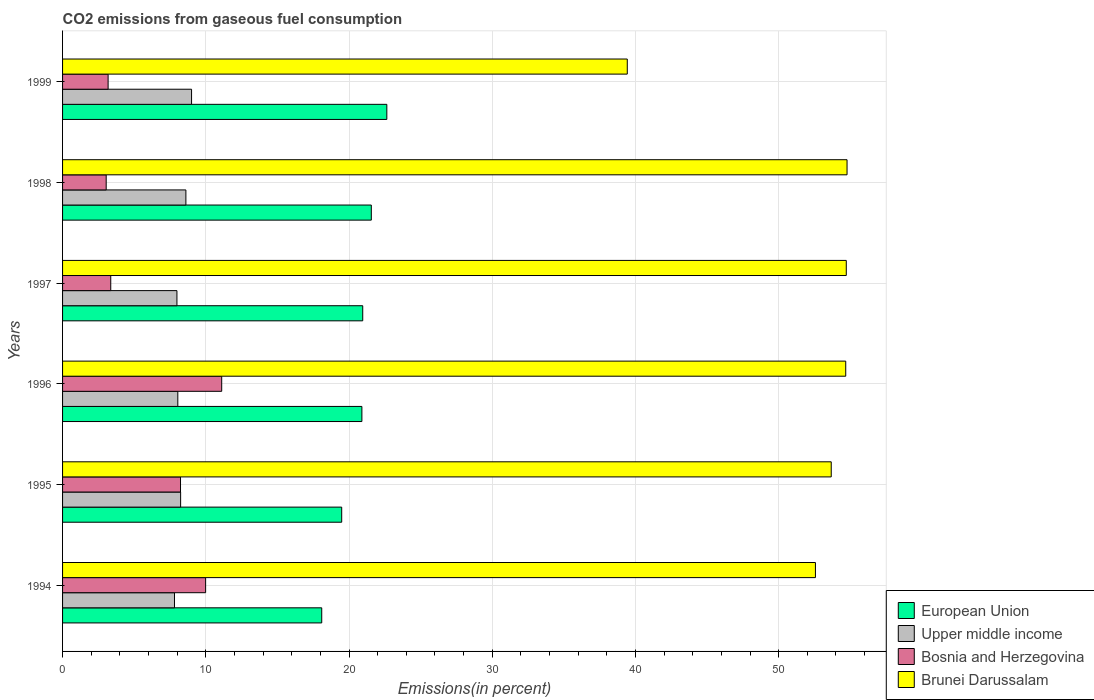Are the number of bars per tick equal to the number of legend labels?
Ensure brevity in your answer.  Yes. Are the number of bars on each tick of the Y-axis equal?
Offer a terse response. Yes. How many bars are there on the 2nd tick from the top?
Your answer should be very brief. 4. How many bars are there on the 2nd tick from the bottom?
Make the answer very short. 4. What is the total CO2 emitted in Bosnia and Herzegovina in 1997?
Provide a short and direct response. 3.36. Across all years, what is the maximum total CO2 emitted in Upper middle income?
Provide a succinct answer. 9.01. Across all years, what is the minimum total CO2 emitted in Bosnia and Herzegovina?
Provide a succinct answer. 3.05. In which year was the total CO2 emitted in European Union minimum?
Your answer should be very brief. 1994. What is the total total CO2 emitted in Bosnia and Herzegovina in the graph?
Your answer should be very brief. 38.93. What is the difference between the total CO2 emitted in Upper middle income in 1998 and that in 1999?
Offer a very short reply. -0.4. What is the difference between the total CO2 emitted in Bosnia and Herzegovina in 1997 and the total CO2 emitted in Brunei Darussalam in 1995?
Your answer should be compact. -50.31. What is the average total CO2 emitted in Upper middle income per year?
Give a very brief answer. 8.28. In the year 1995, what is the difference between the total CO2 emitted in European Union and total CO2 emitted in Bosnia and Herzegovina?
Your answer should be very brief. 11.25. What is the ratio of the total CO2 emitted in Brunei Darussalam in 1996 to that in 1999?
Your answer should be very brief. 1.39. Is the difference between the total CO2 emitted in European Union in 1997 and 1998 greater than the difference between the total CO2 emitted in Bosnia and Herzegovina in 1997 and 1998?
Provide a short and direct response. No. What is the difference between the highest and the second highest total CO2 emitted in Brunei Darussalam?
Your response must be concise. 0.05. What is the difference between the highest and the lowest total CO2 emitted in Brunei Darussalam?
Give a very brief answer. 15.34. In how many years, is the total CO2 emitted in Bosnia and Herzegovina greater than the average total CO2 emitted in Bosnia and Herzegovina taken over all years?
Provide a short and direct response. 3. Is it the case that in every year, the sum of the total CO2 emitted in European Union and total CO2 emitted in Upper middle income is greater than the sum of total CO2 emitted in Brunei Darussalam and total CO2 emitted in Bosnia and Herzegovina?
Your answer should be very brief. Yes. What does the 2nd bar from the top in 1999 represents?
Make the answer very short. Bosnia and Herzegovina. What does the 2nd bar from the bottom in 1996 represents?
Provide a short and direct response. Upper middle income. What is the difference between two consecutive major ticks on the X-axis?
Your response must be concise. 10. Are the values on the major ticks of X-axis written in scientific E-notation?
Offer a terse response. No. Does the graph contain any zero values?
Give a very brief answer. No. How are the legend labels stacked?
Make the answer very short. Vertical. What is the title of the graph?
Offer a very short reply. CO2 emissions from gaseous fuel consumption. What is the label or title of the X-axis?
Give a very brief answer. Emissions(in percent). What is the Emissions(in percent) of European Union in 1994?
Ensure brevity in your answer.  18.09. What is the Emissions(in percent) of Upper middle income in 1994?
Your answer should be very brief. 7.81. What is the Emissions(in percent) of Bosnia and Herzegovina in 1994?
Ensure brevity in your answer.  9.99. What is the Emissions(in percent) in Brunei Darussalam in 1994?
Ensure brevity in your answer.  52.57. What is the Emissions(in percent) of European Union in 1995?
Offer a very short reply. 19.49. What is the Emissions(in percent) of Upper middle income in 1995?
Make the answer very short. 8.24. What is the Emissions(in percent) of Bosnia and Herzegovina in 1995?
Your answer should be very brief. 8.24. What is the Emissions(in percent) of Brunei Darussalam in 1995?
Make the answer very short. 53.67. What is the Emissions(in percent) of European Union in 1996?
Your answer should be compact. 20.9. What is the Emissions(in percent) of Upper middle income in 1996?
Ensure brevity in your answer.  8.05. What is the Emissions(in percent) in Bosnia and Herzegovina in 1996?
Provide a short and direct response. 11.11. What is the Emissions(in percent) of Brunei Darussalam in 1996?
Keep it short and to the point. 54.68. What is the Emissions(in percent) in European Union in 1997?
Your answer should be very brief. 20.96. What is the Emissions(in percent) in Upper middle income in 1997?
Provide a short and direct response. 7.99. What is the Emissions(in percent) in Bosnia and Herzegovina in 1997?
Your answer should be compact. 3.36. What is the Emissions(in percent) in Brunei Darussalam in 1997?
Offer a terse response. 54.72. What is the Emissions(in percent) of European Union in 1998?
Offer a terse response. 21.56. What is the Emissions(in percent) in Upper middle income in 1998?
Your response must be concise. 8.61. What is the Emissions(in percent) of Bosnia and Herzegovina in 1998?
Your answer should be very brief. 3.05. What is the Emissions(in percent) of Brunei Darussalam in 1998?
Provide a short and direct response. 54.77. What is the Emissions(in percent) in European Union in 1999?
Offer a terse response. 22.64. What is the Emissions(in percent) in Upper middle income in 1999?
Your answer should be compact. 9.01. What is the Emissions(in percent) in Bosnia and Herzegovina in 1999?
Provide a succinct answer. 3.18. What is the Emissions(in percent) in Brunei Darussalam in 1999?
Make the answer very short. 39.43. Across all years, what is the maximum Emissions(in percent) in European Union?
Your response must be concise. 22.64. Across all years, what is the maximum Emissions(in percent) of Upper middle income?
Give a very brief answer. 9.01. Across all years, what is the maximum Emissions(in percent) of Bosnia and Herzegovina?
Ensure brevity in your answer.  11.11. Across all years, what is the maximum Emissions(in percent) of Brunei Darussalam?
Ensure brevity in your answer.  54.77. Across all years, what is the minimum Emissions(in percent) of European Union?
Give a very brief answer. 18.09. Across all years, what is the minimum Emissions(in percent) of Upper middle income?
Give a very brief answer. 7.81. Across all years, what is the minimum Emissions(in percent) of Bosnia and Herzegovina?
Provide a short and direct response. 3.05. Across all years, what is the minimum Emissions(in percent) in Brunei Darussalam?
Your answer should be very brief. 39.43. What is the total Emissions(in percent) of European Union in the graph?
Provide a short and direct response. 123.64. What is the total Emissions(in percent) in Upper middle income in the graph?
Ensure brevity in your answer.  49.71. What is the total Emissions(in percent) in Bosnia and Herzegovina in the graph?
Offer a terse response. 38.93. What is the total Emissions(in percent) in Brunei Darussalam in the graph?
Offer a terse response. 309.84. What is the difference between the Emissions(in percent) of European Union in 1994 and that in 1995?
Your response must be concise. -1.39. What is the difference between the Emissions(in percent) in Upper middle income in 1994 and that in 1995?
Provide a succinct answer. -0.43. What is the difference between the Emissions(in percent) of Bosnia and Herzegovina in 1994 and that in 1995?
Make the answer very short. 1.75. What is the difference between the Emissions(in percent) in Brunei Darussalam in 1994 and that in 1995?
Ensure brevity in your answer.  -1.1. What is the difference between the Emissions(in percent) in European Union in 1994 and that in 1996?
Your response must be concise. -2.8. What is the difference between the Emissions(in percent) of Upper middle income in 1994 and that in 1996?
Make the answer very short. -0.23. What is the difference between the Emissions(in percent) of Bosnia and Herzegovina in 1994 and that in 1996?
Offer a terse response. -1.12. What is the difference between the Emissions(in percent) of Brunei Darussalam in 1994 and that in 1996?
Keep it short and to the point. -2.11. What is the difference between the Emissions(in percent) of European Union in 1994 and that in 1997?
Your answer should be compact. -2.86. What is the difference between the Emissions(in percent) of Upper middle income in 1994 and that in 1997?
Provide a succinct answer. -0.17. What is the difference between the Emissions(in percent) in Bosnia and Herzegovina in 1994 and that in 1997?
Make the answer very short. 6.62. What is the difference between the Emissions(in percent) in Brunei Darussalam in 1994 and that in 1997?
Ensure brevity in your answer.  -2.15. What is the difference between the Emissions(in percent) of European Union in 1994 and that in 1998?
Make the answer very short. -3.46. What is the difference between the Emissions(in percent) of Upper middle income in 1994 and that in 1998?
Make the answer very short. -0.8. What is the difference between the Emissions(in percent) in Bosnia and Herzegovina in 1994 and that in 1998?
Make the answer very short. 6.94. What is the difference between the Emissions(in percent) of Brunei Darussalam in 1994 and that in 1998?
Give a very brief answer. -2.21. What is the difference between the Emissions(in percent) in European Union in 1994 and that in 1999?
Provide a short and direct response. -4.55. What is the difference between the Emissions(in percent) in Upper middle income in 1994 and that in 1999?
Provide a short and direct response. -1.19. What is the difference between the Emissions(in percent) of Bosnia and Herzegovina in 1994 and that in 1999?
Provide a succinct answer. 6.81. What is the difference between the Emissions(in percent) of Brunei Darussalam in 1994 and that in 1999?
Provide a succinct answer. 13.14. What is the difference between the Emissions(in percent) of European Union in 1995 and that in 1996?
Your answer should be very brief. -1.41. What is the difference between the Emissions(in percent) of Upper middle income in 1995 and that in 1996?
Your response must be concise. 0.2. What is the difference between the Emissions(in percent) of Bosnia and Herzegovina in 1995 and that in 1996?
Provide a short and direct response. -2.88. What is the difference between the Emissions(in percent) in Brunei Darussalam in 1995 and that in 1996?
Keep it short and to the point. -1.01. What is the difference between the Emissions(in percent) in European Union in 1995 and that in 1997?
Offer a terse response. -1.47. What is the difference between the Emissions(in percent) in Upper middle income in 1995 and that in 1997?
Your answer should be compact. 0.26. What is the difference between the Emissions(in percent) of Bosnia and Herzegovina in 1995 and that in 1997?
Give a very brief answer. 4.87. What is the difference between the Emissions(in percent) in Brunei Darussalam in 1995 and that in 1997?
Keep it short and to the point. -1.05. What is the difference between the Emissions(in percent) of European Union in 1995 and that in 1998?
Make the answer very short. -2.07. What is the difference between the Emissions(in percent) of Upper middle income in 1995 and that in 1998?
Your response must be concise. -0.37. What is the difference between the Emissions(in percent) of Bosnia and Herzegovina in 1995 and that in 1998?
Your response must be concise. 5.19. What is the difference between the Emissions(in percent) in Brunei Darussalam in 1995 and that in 1998?
Ensure brevity in your answer.  -1.1. What is the difference between the Emissions(in percent) of European Union in 1995 and that in 1999?
Provide a short and direct response. -3.15. What is the difference between the Emissions(in percent) in Upper middle income in 1995 and that in 1999?
Make the answer very short. -0.76. What is the difference between the Emissions(in percent) in Bosnia and Herzegovina in 1995 and that in 1999?
Give a very brief answer. 5.06. What is the difference between the Emissions(in percent) in Brunei Darussalam in 1995 and that in 1999?
Offer a terse response. 14.24. What is the difference between the Emissions(in percent) of European Union in 1996 and that in 1997?
Provide a succinct answer. -0.06. What is the difference between the Emissions(in percent) in Upper middle income in 1996 and that in 1997?
Provide a short and direct response. 0.06. What is the difference between the Emissions(in percent) of Bosnia and Herzegovina in 1996 and that in 1997?
Your answer should be very brief. 7.75. What is the difference between the Emissions(in percent) of Brunei Darussalam in 1996 and that in 1997?
Ensure brevity in your answer.  -0.04. What is the difference between the Emissions(in percent) of European Union in 1996 and that in 1998?
Offer a very short reply. -0.66. What is the difference between the Emissions(in percent) of Upper middle income in 1996 and that in 1998?
Give a very brief answer. -0.56. What is the difference between the Emissions(in percent) of Bosnia and Herzegovina in 1996 and that in 1998?
Your response must be concise. 8.07. What is the difference between the Emissions(in percent) in Brunei Darussalam in 1996 and that in 1998?
Your answer should be compact. -0.09. What is the difference between the Emissions(in percent) in European Union in 1996 and that in 1999?
Your answer should be very brief. -1.74. What is the difference between the Emissions(in percent) in Upper middle income in 1996 and that in 1999?
Your answer should be very brief. -0.96. What is the difference between the Emissions(in percent) of Bosnia and Herzegovina in 1996 and that in 1999?
Your answer should be compact. 7.93. What is the difference between the Emissions(in percent) of Brunei Darussalam in 1996 and that in 1999?
Offer a terse response. 15.25. What is the difference between the Emissions(in percent) of European Union in 1997 and that in 1998?
Give a very brief answer. -0.6. What is the difference between the Emissions(in percent) in Upper middle income in 1997 and that in 1998?
Your answer should be very brief. -0.62. What is the difference between the Emissions(in percent) of Bosnia and Herzegovina in 1997 and that in 1998?
Give a very brief answer. 0.32. What is the difference between the Emissions(in percent) of Brunei Darussalam in 1997 and that in 1998?
Your answer should be very brief. -0.05. What is the difference between the Emissions(in percent) of European Union in 1997 and that in 1999?
Give a very brief answer. -1.68. What is the difference between the Emissions(in percent) in Upper middle income in 1997 and that in 1999?
Offer a very short reply. -1.02. What is the difference between the Emissions(in percent) of Bosnia and Herzegovina in 1997 and that in 1999?
Your answer should be very brief. 0.18. What is the difference between the Emissions(in percent) in Brunei Darussalam in 1997 and that in 1999?
Your response must be concise. 15.29. What is the difference between the Emissions(in percent) of European Union in 1998 and that in 1999?
Provide a short and direct response. -1.08. What is the difference between the Emissions(in percent) of Upper middle income in 1998 and that in 1999?
Offer a very short reply. -0.4. What is the difference between the Emissions(in percent) of Bosnia and Herzegovina in 1998 and that in 1999?
Your response must be concise. -0.13. What is the difference between the Emissions(in percent) in Brunei Darussalam in 1998 and that in 1999?
Offer a very short reply. 15.34. What is the difference between the Emissions(in percent) of European Union in 1994 and the Emissions(in percent) of Upper middle income in 1995?
Ensure brevity in your answer.  9.85. What is the difference between the Emissions(in percent) in European Union in 1994 and the Emissions(in percent) in Bosnia and Herzegovina in 1995?
Offer a terse response. 9.86. What is the difference between the Emissions(in percent) in European Union in 1994 and the Emissions(in percent) in Brunei Darussalam in 1995?
Ensure brevity in your answer.  -35.57. What is the difference between the Emissions(in percent) of Upper middle income in 1994 and the Emissions(in percent) of Bosnia and Herzegovina in 1995?
Your response must be concise. -0.42. What is the difference between the Emissions(in percent) of Upper middle income in 1994 and the Emissions(in percent) of Brunei Darussalam in 1995?
Ensure brevity in your answer.  -45.85. What is the difference between the Emissions(in percent) in Bosnia and Herzegovina in 1994 and the Emissions(in percent) in Brunei Darussalam in 1995?
Your response must be concise. -43.68. What is the difference between the Emissions(in percent) of European Union in 1994 and the Emissions(in percent) of Upper middle income in 1996?
Give a very brief answer. 10.05. What is the difference between the Emissions(in percent) in European Union in 1994 and the Emissions(in percent) in Bosnia and Herzegovina in 1996?
Make the answer very short. 6.98. What is the difference between the Emissions(in percent) of European Union in 1994 and the Emissions(in percent) of Brunei Darussalam in 1996?
Your answer should be compact. -36.59. What is the difference between the Emissions(in percent) of Upper middle income in 1994 and the Emissions(in percent) of Bosnia and Herzegovina in 1996?
Offer a terse response. -3.3. What is the difference between the Emissions(in percent) of Upper middle income in 1994 and the Emissions(in percent) of Brunei Darussalam in 1996?
Give a very brief answer. -46.87. What is the difference between the Emissions(in percent) of Bosnia and Herzegovina in 1994 and the Emissions(in percent) of Brunei Darussalam in 1996?
Offer a very short reply. -44.69. What is the difference between the Emissions(in percent) of European Union in 1994 and the Emissions(in percent) of Upper middle income in 1997?
Provide a succinct answer. 10.11. What is the difference between the Emissions(in percent) in European Union in 1994 and the Emissions(in percent) in Bosnia and Herzegovina in 1997?
Your answer should be compact. 14.73. What is the difference between the Emissions(in percent) of European Union in 1994 and the Emissions(in percent) of Brunei Darussalam in 1997?
Give a very brief answer. -36.62. What is the difference between the Emissions(in percent) of Upper middle income in 1994 and the Emissions(in percent) of Bosnia and Herzegovina in 1997?
Your answer should be very brief. 4.45. What is the difference between the Emissions(in percent) of Upper middle income in 1994 and the Emissions(in percent) of Brunei Darussalam in 1997?
Your response must be concise. -46.91. What is the difference between the Emissions(in percent) of Bosnia and Herzegovina in 1994 and the Emissions(in percent) of Brunei Darussalam in 1997?
Give a very brief answer. -44.73. What is the difference between the Emissions(in percent) in European Union in 1994 and the Emissions(in percent) in Upper middle income in 1998?
Your answer should be compact. 9.48. What is the difference between the Emissions(in percent) in European Union in 1994 and the Emissions(in percent) in Bosnia and Herzegovina in 1998?
Give a very brief answer. 15.05. What is the difference between the Emissions(in percent) in European Union in 1994 and the Emissions(in percent) in Brunei Darussalam in 1998?
Offer a terse response. -36.68. What is the difference between the Emissions(in percent) in Upper middle income in 1994 and the Emissions(in percent) in Bosnia and Herzegovina in 1998?
Your answer should be compact. 4.77. What is the difference between the Emissions(in percent) of Upper middle income in 1994 and the Emissions(in percent) of Brunei Darussalam in 1998?
Ensure brevity in your answer.  -46.96. What is the difference between the Emissions(in percent) of Bosnia and Herzegovina in 1994 and the Emissions(in percent) of Brunei Darussalam in 1998?
Give a very brief answer. -44.78. What is the difference between the Emissions(in percent) in European Union in 1994 and the Emissions(in percent) in Upper middle income in 1999?
Offer a very short reply. 9.09. What is the difference between the Emissions(in percent) of European Union in 1994 and the Emissions(in percent) of Bosnia and Herzegovina in 1999?
Make the answer very short. 14.91. What is the difference between the Emissions(in percent) in European Union in 1994 and the Emissions(in percent) in Brunei Darussalam in 1999?
Give a very brief answer. -21.33. What is the difference between the Emissions(in percent) of Upper middle income in 1994 and the Emissions(in percent) of Bosnia and Herzegovina in 1999?
Your answer should be compact. 4.63. What is the difference between the Emissions(in percent) of Upper middle income in 1994 and the Emissions(in percent) of Brunei Darussalam in 1999?
Keep it short and to the point. -31.61. What is the difference between the Emissions(in percent) of Bosnia and Herzegovina in 1994 and the Emissions(in percent) of Brunei Darussalam in 1999?
Offer a very short reply. -29.44. What is the difference between the Emissions(in percent) in European Union in 1995 and the Emissions(in percent) in Upper middle income in 1996?
Provide a short and direct response. 11.44. What is the difference between the Emissions(in percent) in European Union in 1995 and the Emissions(in percent) in Bosnia and Herzegovina in 1996?
Your answer should be compact. 8.38. What is the difference between the Emissions(in percent) in European Union in 1995 and the Emissions(in percent) in Brunei Darussalam in 1996?
Keep it short and to the point. -35.19. What is the difference between the Emissions(in percent) of Upper middle income in 1995 and the Emissions(in percent) of Bosnia and Herzegovina in 1996?
Your answer should be very brief. -2.87. What is the difference between the Emissions(in percent) in Upper middle income in 1995 and the Emissions(in percent) in Brunei Darussalam in 1996?
Your response must be concise. -46.44. What is the difference between the Emissions(in percent) in Bosnia and Herzegovina in 1995 and the Emissions(in percent) in Brunei Darussalam in 1996?
Provide a short and direct response. -46.45. What is the difference between the Emissions(in percent) of European Union in 1995 and the Emissions(in percent) of Upper middle income in 1997?
Your response must be concise. 11.5. What is the difference between the Emissions(in percent) of European Union in 1995 and the Emissions(in percent) of Bosnia and Herzegovina in 1997?
Offer a very short reply. 16.13. What is the difference between the Emissions(in percent) of European Union in 1995 and the Emissions(in percent) of Brunei Darussalam in 1997?
Offer a terse response. -35.23. What is the difference between the Emissions(in percent) in Upper middle income in 1995 and the Emissions(in percent) in Bosnia and Herzegovina in 1997?
Ensure brevity in your answer.  4.88. What is the difference between the Emissions(in percent) in Upper middle income in 1995 and the Emissions(in percent) in Brunei Darussalam in 1997?
Offer a very short reply. -46.48. What is the difference between the Emissions(in percent) of Bosnia and Herzegovina in 1995 and the Emissions(in percent) of Brunei Darussalam in 1997?
Your answer should be compact. -46.48. What is the difference between the Emissions(in percent) of European Union in 1995 and the Emissions(in percent) of Upper middle income in 1998?
Provide a succinct answer. 10.88. What is the difference between the Emissions(in percent) of European Union in 1995 and the Emissions(in percent) of Bosnia and Herzegovina in 1998?
Offer a terse response. 16.44. What is the difference between the Emissions(in percent) of European Union in 1995 and the Emissions(in percent) of Brunei Darussalam in 1998?
Your response must be concise. -35.28. What is the difference between the Emissions(in percent) of Upper middle income in 1995 and the Emissions(in percent) of Bosnia and Herzegovina in 1998?
Make the answer very short. 5.2. What is the difference between the Emissions(in percent) of Upper middle income in 1995 and the Emissions(in percent) of Brunei Darussalam in 1998?
Make the answer very short. -46.53. What is the difference between the Emissions(in percent) of Bosnia and Herzegovina in 1995 and the Emissions(in percent) of Brunei Darussalam in 1998?
Offer a very short reply. -46.54. What is the difference between the Emissions(in percent) of European Union in 1995 and the Emissions(in percent) of Upper middle income in 1999?
Provide a short and direct response. 10.48. What is the difference between the Emissions(in percent) in European Union in 1995 and the Emissions(in percent) in Bosnia and Herzegovina in 1999?
Your answer should be very brief. 16.31. What is the difference between the Emissions(in percent) of European Union in 1995 and the Emissions(in percent) of Brunei Darussalam in 1999?
Your answer should be compact. -19.94. What is the difference between the Emissions(in percent) of Upper middle income in 1995 and the Emissions(in percent) of Bosnia and Herzegovina in 1999?
Keep it short and to the point. 5.06. What is the difference between the Emissions(in percent) of Upper middle income in 1995 and the Emissions(in percent) of Brunei Darussalam in 1999?
Provide a succinct answer. -31.19. What is the difference between the Emissions(in percent) in Bosnia and Herzegovina in 1995 and the Emissions(in percent) in Brunei Darussalam in 1999?
Make the answer very short. -31.19. What is the difference between the Emissions(in percent) of European Union in 1996 and the Emissions(in percent) of Upper middle income in 1997?
Provide a short and direct response. 12.91. What is the difference between the Emissions(in percent) in European Union in 1996 and the Emissions(in percent) in Bosnia and Herzegovina in 1997?
Your response must be concise. 17.54. What is the difference between the Emissions(in percent) of European Union in 1996 and the Emissions(in percent) of Brunei Darussalam in 1997?
Offer a terse response. -33.82. What is the difference between the Emissions(in percent) of Upper middle income in 1996 and the Emissions(in percent) of Bosnia and Herzegovina in 1997?
Offer a very short reply. 4.68. What is the difference between the Emissions(in percent) in Upper middle income in 1996 and the Emissions(in percent) in Brunei Darussalam in 1997?
Keep it short and to the point. -46.67. What is the difference between the Emissions(in percent) of Bosnia and Herzegovina in 1996 and the Emissions(in percent) of Brunei Darussalam in 1997?
Your response must be concise. -43.61. What is the difference between the Emissions(in percent) in European Union in 1996 and the Emissions(in percent) in Upper middle income in 1998?
Your answer should be compact. 12.29. What is the difference between the Emissions(in percent) in European Union in 1996 and the Emissions(in percent) in Bosnia and Herzegovina in 1998?
Offer a terse response. 17.85. What is the difference between the Emissions(in percent) of European Union in 1996 and the Emissions(in percent) of Brunei Darussalam in 1998?
Your response must be concise. -33.87. What is the difference between the Emissions(in percent) of Upper middle income in 1996 and the Emissions(in percent) of Bosnia and Herzegovina in 1998?
Offer a terse response. 5. What is the difference between the Emissions(in percent) of Upper middle income in 1996 and the Emissions(in percent) of Brunei Darussalam in 1998?
Your answer should be very brief. -46.73. What is the difference between the Emissions(in percent) in Bosnia and Herzegovina in 1996 and the Emissions(in percent) in Brunei Darussalam in 1998?
Keep it short and to the point. -43.66. What is the difference between the Emissions(in percent) of European Union in 1996 and the Emissions(in percent) of Upper middle income in 1999?
Your answer should be very brief. 11.89. What is the difference between the Emissions(in percent) of European Union in 1996 and the Emissions(in percent) of Bosnia and Herzegovina in 1999?
Ensure brevity in your answer.  17.72. What is the difference between the Emissions(in percent) in European Union in 1996 and the Emissions(in percent) in Brunei Darussalam in 1999?
Your answer should be very brief. -18.53. What is the difference between the Emissions(in percent) of Upper middle income in 1996 and the Emissions(in percent) of Bosnia and Herzegovina in 1999?
Give a very brief answer. 4.87. What is the difference between the Emissions(in percent) of Upper middle income in 1996 and the Emissions(in percent) of Brunei Darussalam in 1999?
Offer a terse response. -31.38. What is the difference between the Emissions(in percent) in Bosnia and Herzegovina in 1996 and the Emissions(in percent) in Brunei Darussalam in 1999?
Give a very brief answer. -28.32. What is the difference between the Emissions(in percent) in European Union in 1997 and the Emissions(in percent) in Upper middle income in 1998?
Your answer should be compact. 12.35. What is the difference between the Emissions(in percent) in European Union in 1997 and the Emissions(in percent) in Bosnia and Herzegovina in 1998?
Your answer should be compact. 17.91. What is the difference between the Emissions(in percent) in European Union in 1997 and the Emissions(in percent) in Brunei Darussalam in 1998?
Provide a short and direct response. -33.82. What is the difference between the Emissions(in percent) in Upper middle income in 1997 and the Emissions(in percent) in Bosnia and Herzegovina in 1998?
Ensure brevity in your answer.  4.94. What is the difference between the Emissions(in percent) in Upper middle income in 1997 and the Emissions(in percent) in Brunei Darussalam in 1998?
Offer a terse response. -46.79. What is the difference between the Emissions(in percent) of Bosnia and Herzegovina in 1997 and the Emissions(in percent) of Brunei Darussalam in 1998?
Make the answer very short. -51.41. What is the difference between the Emissions(in percent) in European Union in 1997 and the Emissions(in percent) in Upper middle income in 1999?
Your answer should be very brief. 11.95. What is the difference between the Emissions(in percent) of European Union in 1997 and the Emissions(in percent) of Bosnia and Herzegovina in 1999?
Ensure brevity in your answer.  17.78. What is the difference between the Emissions(in percent) of European Union in 1997 and the Emissions(in percent) of Brunei Darussalam in 1999?
Offer a terse response. -18.47. What is the difference between the Emissions(in percent) of Upper middle income in 1997 and the Emissions(in percent) of Bosnia and Herzegovina in 1999?
Your answer should be compact. 4.81. What is the difference between the Emissions(in percent) in Upper middle income in 1997 and the Emissions(in percent) in Brunei Darussalam in 1999?
Provide a short and direct response. -31.44. What is the difference between the Emissions(in percent) of Bosnia and Herzegovina in 1997 and the Emissions(in percent) of Brunei Darussalam in 1999?
Offer a terse response. -36.06. What is the difference between the Emissions(in percent) in European Union in 1998 and the Emissions(in percent) in Upper middle income in 1999?
Offer a terse response. 12.55. What is the difference between the Emissions(in percent) in European Union in 1998 and the Emissions(in percent) in Bosnia and Herzegovina in 1999?
Keep it short and to the point. 18.38. What is the difference between the Emissions(in percent) in European Union in 1998 and the Emissions(in percent) in Brunei Darussalam in 1999?
Provide a short and direct response. -17.87. What is the difference between the Emissions(in percent) in Upper middle income in 1998 and the Emissions(in percent) in Bosnia and Herzegovina in 1999?
Offer a very short reply. 5.43. What is the difference between the Emissions(in percent) in Upper middle income in 1998 and the Emissions(in percent) in Brunei Darussalam in 1999?
Ensure brevity in your answer.  -30.82. What is the difference between the Emissions(in percent) of Bosnia and Herzegovina in 1998 and the Emissions(in percent) of Brunei Darussalam in 1999?
Keep it short and to the point. -36.38. What is the average Emissions(in percent) of European Union per year?
Offer a terse response. 20.61. What is the average Emissions(in percent) in Upper middle income per year?
Your response must be concise. 8.28. What is the average Emissions(in percent) of Bosnia and Herzegovina per year?
Provide a short and direct response. 6.49. What is the average Emissions(in percent) of Brunei Darussalam per year?
Your answer should be compact. 51.64. In the year 1994, what is the difference between the Emissions(in percent) of European Union and Emissions(in percent) of Upper middle income?
Give a very brief answer. 10.28. In the year 1994, what is the difference between the Emissions(in percent) of European Union and Emissions(in percent) of Bosnia and Herzegovina?
Provide a short and direct response. 8.11. In the year 1994, what is the difference between the Emissions(in percent) of European Union and Emissions(in percent) of Brunei Darussalam?
Provide a succinct answer. -34.47. In the year 1994, what is the difference between the Emissions(in percent) of Upper middle income and Emissions(in percent) of Bosnia and Herzegovina?
Your answer should be very brief. -2.17. In the year 1994, what is the difference between the Emissions(in percent) of Upper middle income and Emissions(in percent) of Brunei Darussalam?
Your answer should be very brief. -44.75. In the year 1994, what is the difference between the Emissions(in percent) of Bosnia and Herzegovina and Emissions(in percent) of Brunei Darussalam?
Provide a succinct answer. -42.58. In the year 1995, what is the difference between the Emissions(in percent) in European Union and Emissions(in percent) in Upper middle income?
Your response must be concise. 11.25. In the year 1995, what is the difference between the Emissions(in percent) in European Union and Emissions(in percent) in Bosnia and Herzegovina?
Ensure brevity in your answer.  11.25. In the year 1995, what is the difference between the Emissions(in percent) in European Union and Emissions(in percent) in Brunei Darussalam?
Your answer should be compact. -34.18. In the year 1995, what is the difference between the Emissions(in percent) of Upper middle income and Emissions(in percent) of Bosnia and Herzegovina?
Provide a succinct answer. 0.01. In the year 1995, what is the difference between the Emissions(in percent) in Upper middle income and Emissions(in percent) in Brunei Darussalam?
Keep it short and to the point. -45.43. In the year 1995, what is the difference between the Emissions(in percent) of Bosnia and Herzegovina and Emissions(in percent) of Brunei Darussalam?
Offer a terse response. -45.43. In the year 1996, what is the difference between the Emissions(in percent) in European Union and Emissions(in percent) in Upper middle income?
Keep it short and to the point. 12.85. In the year 1996, what is the difference between the Emissions(in percent) of European Union and Emissions(in percent) of Bosnia and Herzegovina?
Make the answer very short. 9.79. In the year 1996, what is the difference between the Emissions(in percent) of European Union and Emissions(in percent) of Brunei Darussalam?
Your answer should be very brief. -33.78. In the year 1996, what is the difference between the Emissions(in percent) of Upper middle income and Emissions(in percent) of Bosnia and Herzegovina?
Keep it short and to the point. -3.06. In the year 1996, what is the difference between the Emissions(in percent) of Upper middle income and Emissions(in percent) of Brunei Darussalam?
Your answer should be very brief. -46.63. In the year 1996, what is the difference between the Emissions(in percent) of Bosnia and Herzegovina and Emissions(in percent) of Brunei Darussalam?
Your answer should be compact. -43.57. In the year 1997, what is the difference between the Emissions(in percent) in European Union and Emissions(in percent) in Upper middle income?
Provide a succinct answer. 12.97. In the year 1997, what is the difference between the Emissions(in percent) of European Union and Emissions(in percent) of Bosnia and Herzegovina?
Make the answer very short. 17.59. In the year 1997, what is the difference between the Emissions(in percent) in European Union and Emissions(in percent) in Brunei Darussalam?
Provide a succinct answer. -33.76. In the year 1997, what is the difference between the Emissions(in percent) in Upper middle income and Emissions(in percent) in Bosnia and Herzegovina?
Provide a short and direct response. 4.62. In the year 1997, what is the difference between the Emissions(in percent) of Upper middle income and Emissions(in percent) of Brunei Darussalam?
Your answer should be very brief. -46.73. In the year 1997, what is the difference between the Emissions(in percent) in Bosnia and Herzegovina and Emissions(in percent) in Brunei Darussalam?
Make the answer very short. -51.36. In the year 1998, what is the difference between the Emissions(in percent) of European Union and Emissions(in percent) of Upper middle income?
Offer a very short reply. 12.95. In the year 1998, what is the difference between the Emissions(in percent) in European Union and Emissions(in percent) in Bosnia and Herzegovina?
Ensure brevity in your answer.  18.51. In the year 1998, what is the difference between the Emissions(in percent) of European Union and Emissions(in percent) of Brunei Darussalam?
Keep it short and to the point. -33.22. In the year 1998, what is the difference between the Emissions(in percent) of Upper middle income and Emissions(in percent) of Bosnia and Herzegovina?
Make the answer very short. 5.56. In the year 1998, what is the difference between the Emissions(in percent) of Upper middle income and Emissions(in percent) of Brunei Darussalam?
Ensure brevity in your answer.  -46.16. In the year 1998, what is the difference between the Emissions(in percent) in Bosnia and Herzegovina and Emissions(in percent) in Brunei Darussalam?
Your answer should be very brief. -51.73. In the year 1999, what is the difference between the Emissions(in percent) in European Union and Emissions(in percent) in Upper middle income?
Keep it short and to the point. 13.63. In the year 1999, what is the difference between the Emissions(in percent) of European Union and Emissions(in percent) of Bosnia and Herzegovina?
Provide a succinct answer. 19.46. In the year 1999, what is the difference between the Emissions(in percent) in European Union and Emissions(in percent) in Brunei Darussalam?
Give a very brief answer. -16.79. In the year 1999, what is the difference between the Emissions(in percent) in Upper middle income and Emissions(in percent) in Bosnia and Herzegovina?
Give a very brief answer. 5.83. In the year 1999, what is the difference between the Emissions(in percent) in Upper middle income and Emissions(in percent) in Brunei Darussalam?
Keep it short and to the point. -30.42. In the year 1999, what is the difference between the Emissions(in percent) of Bosnia and Herzegovina and Emissions(in percent) of Brunei Darussalam?
Provide a succinct answer. -36.25. What is the ratio of the Emissions(in percent) in European Union in 1994 to that in 1995?
Your response must be concise. 0.93. What is the ratio of the Emissions(in percent) in Upper middle income in 1994 to that in 1995?
Offer a very short reply. 0.95. What is the ratio of the Emissions(in percent) in Bosnia and Herzegovina in 1994 to that in 1995?
Ensure brevity in your answer.  1.21. What is the ratio of the Emissions(in percent) of Brunei Darussalam in 1994 to that in 1995?
Offer a terse response. 0.98. What is the ratio of the Emissions(in percent) in European Union in 1994 to that in 1996?
Give a very brief answer. 0.87. What is the ratio of the Emissions(in percent) of Upper middle income in 1994 to that in 1996?
Your answer should be very brief. 0.97. What is the ratio of the Emissions(in percent) in Bosnia and Herzegovina in 1994 to that in 1996?
Give a very brief answer. 0.9. What is the ratio of the Emissions(in percent) of Brunei Darussalam in 1994 to that in 1996?
Give a very brief answer. 0.96. What is the ratio of the Emissions(in percent) of European Union in 1994 to that in 1997?
Offer a very short reply. 0.86. What is the ratio of the Emissions(in percent) of Upper middle income in 1994 to that in 1997?
Offer a terse response. 0.98. What is the ratio of the Emissions(in percent) of Bosnia and Herzegovina in 1994 to that in 1997?
Your response must be concise. 2.97. What is the ratio of the Emissions(in percent) of Brunei Darussalam in 1994 to that in 1997?
Provide a succinct answer. 0.96. What is the ratio of the Emissions(in percent) in European Union in 1994 to that in 1998?
Give a very brief answer. 0.84. What is the ratio of the Emissions(in percent) of Upper middle income in 1994 to that in 1998?
Provide a short and direct response. 0.91. What is the ratio of the Emissions(in percent) of Bosnia and Herzegovina in 1994 to that in 1998?
Ensure brevity in your answer.  3.28. What is the ratio of the Emissions(in percent) in Brunei Darussalam in 1994 to that in 1998?
Provide a short and direct response. 0.96. What is the ratio of the Emissions(in percent) of European Union in 1994 to that in 1999?
Keep it short and to the point. 0.8. What is the ratio of the Emissions(in percent) in Upper middle income in 1994 to that in 1999?
Keep it short and to the point. 0.87. What is the ratio of the Emissions(in percent) of Bosnia and Herzegovina in 1994 to that in 1999?
Your answer should be compact. 3.14. What is the ratio of the Emissions(in percent) in Brunei Darussalam in 1994 to that in 1999?
Offer a terse response. 1.33. What is the ratio of the Emissions(in percent) of European Union in 1995 to that in 1996?
Ensure brevity in your answer.  0.93. What is the ratio of the Emissions(in percent) in Upper middle income in 1995 to that in 1996?
Keep it short and to the point. 1.02. What is the ratio of the Emissions(in percent) in Bosnia and Herzegovina in 1995 to that in 1996?
Your answer should be compact. 0.74. What is the ratio of the Emissions(in percent) of Brunei Darussalam in 1995 to that in 1996?
Ensure brevity in your answer.  0.98. What is the ratio of the Emissions(in percent) of European Union in 1995 to that in 1997?
Make the answer very short. 0.93. What is the ratio of the Emissions(in percent) of Upper middle income in 1995 to that in 1997?
Offer a terse response. 1.03. What is the ratio of the Emissions(in percent) of Bosnia and Herzegovina in 1995 to that in 1997?
Your answer should be compact. 2.45. What is the ratio of the Emissions(in percent) in Brunei Darussalam in 1995 to that in 1997?
Ensure brevity in your answer.  0.98. What is the ratio of the Emissions(in percent) of European Union in 1995 to that in 1998?
Make the answer very short. 0.9. What is the ratio of the Emissions(in percent) in Upper middle income in 1995 to that in 1998?
Offer a very short reply. 0.96. What is the ratio of the Emissions(in percent) of Bosnia and Herzegovina in 1995 to that in 1998?
Your answer should be compact. 2.7. What is the ratio of the Emissions(in percent) in Brunei Darussalam in 1995 to that in 1998?
Keep it short and to the point. 0.98. What is the ratio of the Emissions(in percent) in European Union in 1995 to that in 1999?
Your answer should be very brief. 0.86. What is the ratio of the Emissions(in percent) in Upper middle income in 1995 to that in 1999?
Your response must be concise. 0.92. What is the ratio of the Emissions(in percent) of Bosnia and Herzegovina in 1995 to that in 1999?
Provide a succinct answer. 2.59. What is the ratio of the Emissions(in percent) of Brunei Darussalam in 1995 to that in 1999?
Your answer should be very brief. 1.36. What is the ratio of the Emissions(in percent) of European Union in 1996 to that in 1997?
Your answer should be compact. 1. What is the ratio of the Emissions(in percent) in Upper middle income in 1996 to that in 1997?
Provide a short and direct response. 1.01. What is the ratio of the Emissions(in percent) in Bosnia and Herzegovina in 1996 to that in 1997?
Offer a very short reply. 3.3. What is the ratio of the Emissions(in percent) in European Union in 1996 to that in 1998?
Your answer should be compact. 0.97. What is the ratio of the Emissions(in percent) of Upper middle income in 1996 to that in 1998?
Your answer should be very brief. 0.93. What is the ratio of the Emissions(in percent) in Bosnia and Herzegovina in 1996 to that in 1998?
Ensure brevity in your answer.  3.65. What is the ratio of the Emissions(in percent) of Upper middle income in 1996 to that in 1999?
Your answer should be very brief. 0.89. What is the ratio of the Emissions(in percent) of Bosnia and Herzegovina in 1996 to that in 1999?
Offer a terse response. 3.49. What is the ratio of the Emissions(in percent) of Brunei Darussalam in 1996 to that in 1999?
Your answer should be very brief. 1.39. What is the ratio of the Emissions(in percent) in European Union in 1997 to that in 1998?
Provide a short and direct response. 0.97. What is the ratio of the Emissions(in percent) in Upper middle income in 1997 to that in 1998?
Offer a very short reply. 0.93. What is the ratio of the Emissions(in percent) in Bosnia and Herzegovina in 1997 to that in 1998?
Your answer should be compact. 1.1. What is the ratio of the Emissions(in percent) of Brunei Darussalam in 1997 to that in 1998?
Your answer should be compact. 1. What is the ratio of the Emissions(in percent) of European Union in 1997 to that in 1999?
Make the answer very short. 0.93. What is the ratio of the Emissions(in percent) of Upper middle income in 1997 to that in 1999?
Your response must be concise. 0.89. What is the ratio of the Emissions(in percent) of Bosnia and Herzegovina in 1997 to that in 1999?
Ensure brevity in your answer.  1.06. What is the ratio of the Emissions(in percent) of Brunei Darussalam in 1997 to that in 1999?
Provide a succinct answer. 1.39. What is the ratio of the Emissions(in percent) in European Union in 1998 to that in 1999?
Make the answer very short. 0.95. What is the ratio of the Emissions(in percent) of Upper middle income in 1998 to that in 1999?
Keep it short and to the point. 0.96. What is the ratio of the Emissions(in percent) of Bosnia and Herzegovina in 1998 to that in 1999?
Make the answer very short. 0.96. What is the ratio of the Emissions(in percent) of Brunei Darussalam in 1998 to that in 1999?
Give a very brief answer. 1.39. What is the difference between the highest and the second highest Emissions(in percent) of European Union?
Your response must be concise. 1.08. What is the difference between the highest and the second highest Emissions(in percent) in Upper middle income?
Keep it short and to the point. 0.4. What is the difference between the highest and the second highest Emissions(in percent) of Bosnia and Herzegovina?
Keep it short and to the point. 1.12. What is the difference between the highest and the second highest Emissions(in percent) of Brunei Darussalam?
Your answer should be compact. 0.05. What is the difference between the highest and the lowest Emissions(in percent) in European Union?
Your answer should be compact. 4.55. What is the difference between the highest and the lowest Emissions(in percent) in Upper middle income?
Offer a terse response. 1.19. What is the difference between the highest and the lowest Emissions(in percent) in Bosnia and Herzegovina?
Offer a terse response. 8.07. What is the difference between the highest and the lowest Emissions(in percent) in Brunei Darussalam?
Your response must be concise. 15.34. 